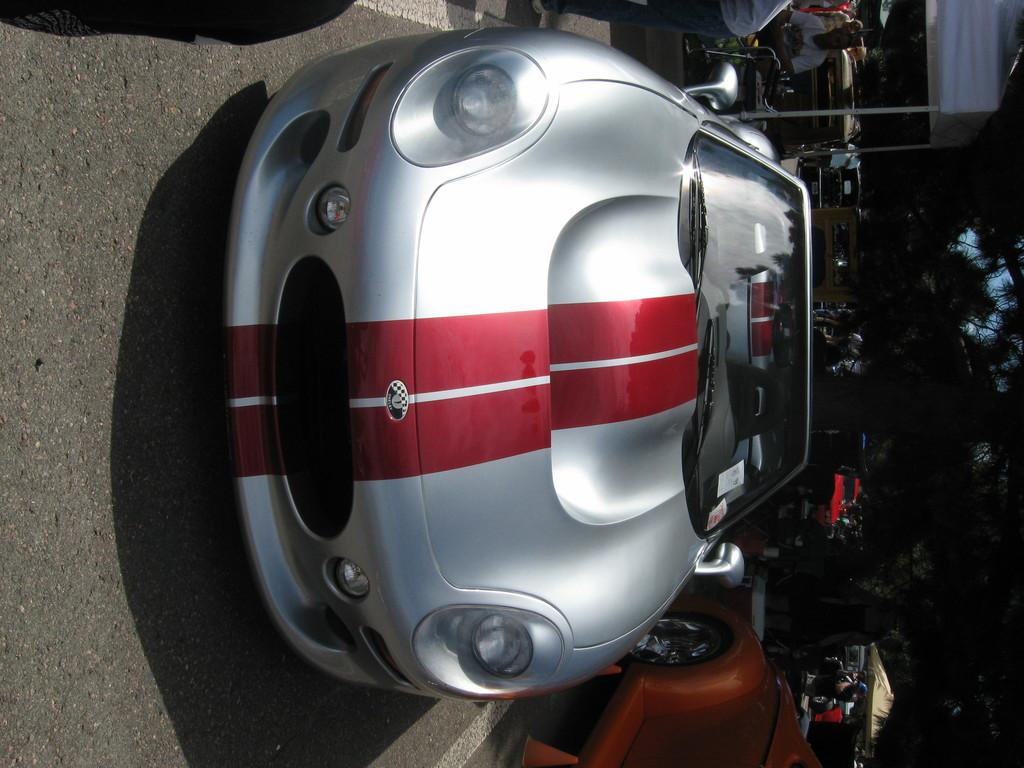What can be seen on the road in the image? There are vehicles on the road in the image. What is visible in the background behind the vehicles? There are tents and trees in the background, as well as people. Can you see anyone jumping in the image? There is no one jumping in the image; the focus is on the vehicles, tents, trees, and people. 